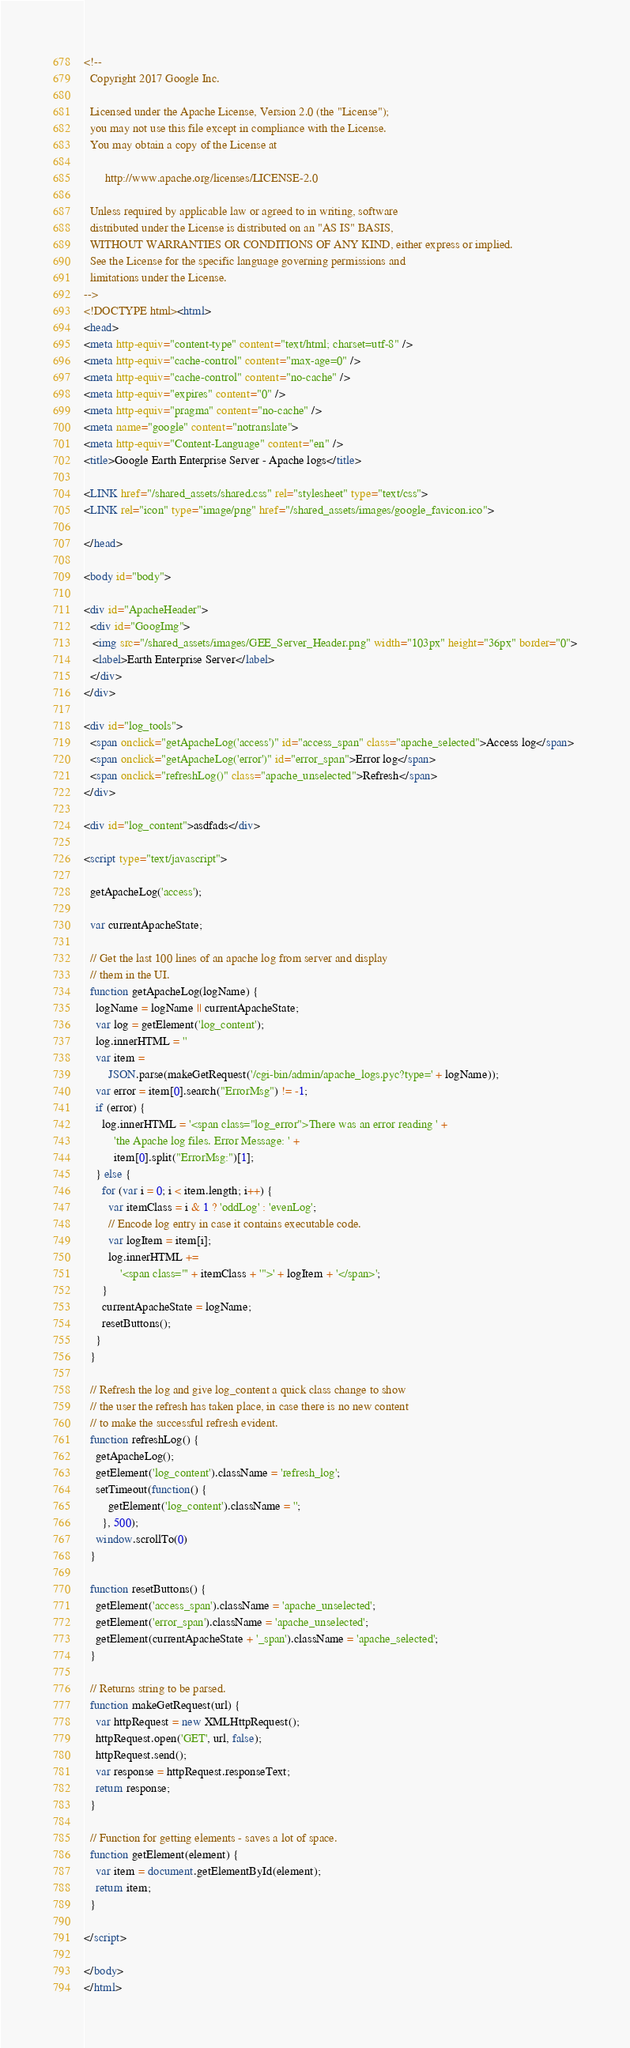<code> <loc_0><loc_0><loc_500><loc_500><_HTML_><!--
  Copyright 2017 Google Inc.

  Licensed under the Apache License, Version 2.0 (the "License");
  you may not use this file except in compliance with the License.
  You may obtain a copy of the License at

       http://www.apache.org/licenses/LICENSE-2.0

  Unless required by applicable law or agreed to in writing, software
  distributed under the License is distributed on an "AS IS" BASIS,
  WITHOUT WARRANTIES OR CONDITIONS OF ANY KIND, either express or implied.
  See the License for the specific language governing permissions and
  limitations under the License.
-->
<!DOCTYPE html><html>
<head>
<meta http-equiv="content-type" content="text/html; charset=utf-8" />
<meta http-equiv="cache-control" content="max-age=0" />
<meta http-equiv="cache-control" content="no-cache" />
<meta http-equiv="expires" content="0" />
<meta http-equiv="pragma" content="no-cache" />
<meta name="google" content="notranslate">
<meta http-equiv="Content-Language" content="en" />
<title>Google Earth Enterprise Server - Apache logs</title>

<LINK href="/shared_assets/shared.css" rel="stylesheet" type="text/css">
<LINK rel="icon" type="image/png" href="/shared_assets/images/google_favicon.ico">

</head>

<body id="body">

<div id="ApacheHeader">
  <div id="GoogImg">
   <img src="/shared_assets/images/GEE_Server_Header.png" width="103px" height="36px" border="0">
   <label>Earth Enterprise Server</label>
  </div>
</div>

<div id="log_tools">
  <span onclick="getApacheLog('access')" id="access_span" class="apache_selected">Access log</span>
  <span onclick="getApacheLog('error')" id="error_span">Error log</span>
  <span onclick="refreshLog()" class="apache_unselected">Refresh</span>
</div>

<div id="log_content">asdfads</div>

<script type="text/javascript">

  getApacheLog('access');

  var currentApacheState;

  // Get the last 100 lines of an apache log from server and display
  // them in the UI.
  function getApacheLog(logName) {
    logName = logName || currentApacheState;
    var log = getElement('log_content');
    log.innerHTML = ''
    var item =
        JSON.parse(makeGetRequest('/cgi-bin/admin/apache_logs.pyc?type=' + logName));
    var error = item[0].search("ErrorMsg") != -1;
    if (error) {
      log.innerHTML = '<span class="log_error">There was an error reading ' +
          'the Apache log files. Error Message: ' +
          item[0].split("ErrorMsg:")[1];
    } else {
      for (var i = 0; i < item.length; i++) {
        var itemClass = i & 1 ? 'oddLog' : 'evenLog';
        // Encode log entry in case it contains executable code.
        var logItem = item[i];
        log.innerHTML +=
            '<span class="' + itemClass + '">' + logItem + '</span>';
      }
      currentApacheState = logName;
      resetButtons();
    }
  }

  // Refresh the log and give log_content a quick class change to show
  // the user the refresh has taken place, in case there is no new content
  // to make the successful refresh evident.
  function refreshLog() {
    getApacheLog();
    getElement('log_content').className = 'refresh_log';
    setTimeout(function() {
        getElement('log_content').className = '';
      }, 500);
    window.scrollTo(0)
  }

  function resetButtons() {
    getElement('access_span').className = 'apache_unselected';
    getElement('error_span').className = 'apache_unselected';
    getElement(currentApacheState + '_span').className = 'apache_selected';
  }

  // Returns string to be parsed.
  function makeGetRequest(url) {
    var httpRequest = new XMLHttpRequest();
    httpRequest.open('GET', url, false);
    httpRequest.send();
    var response = httpRequest.responseText;
    return response;
  }

  // Function for getting elements - saves a lot of space.
  function getElement(element) {
    var item = document.getElementById(element);
    return item;
  }

</script>

</body>
</html>
</code> 